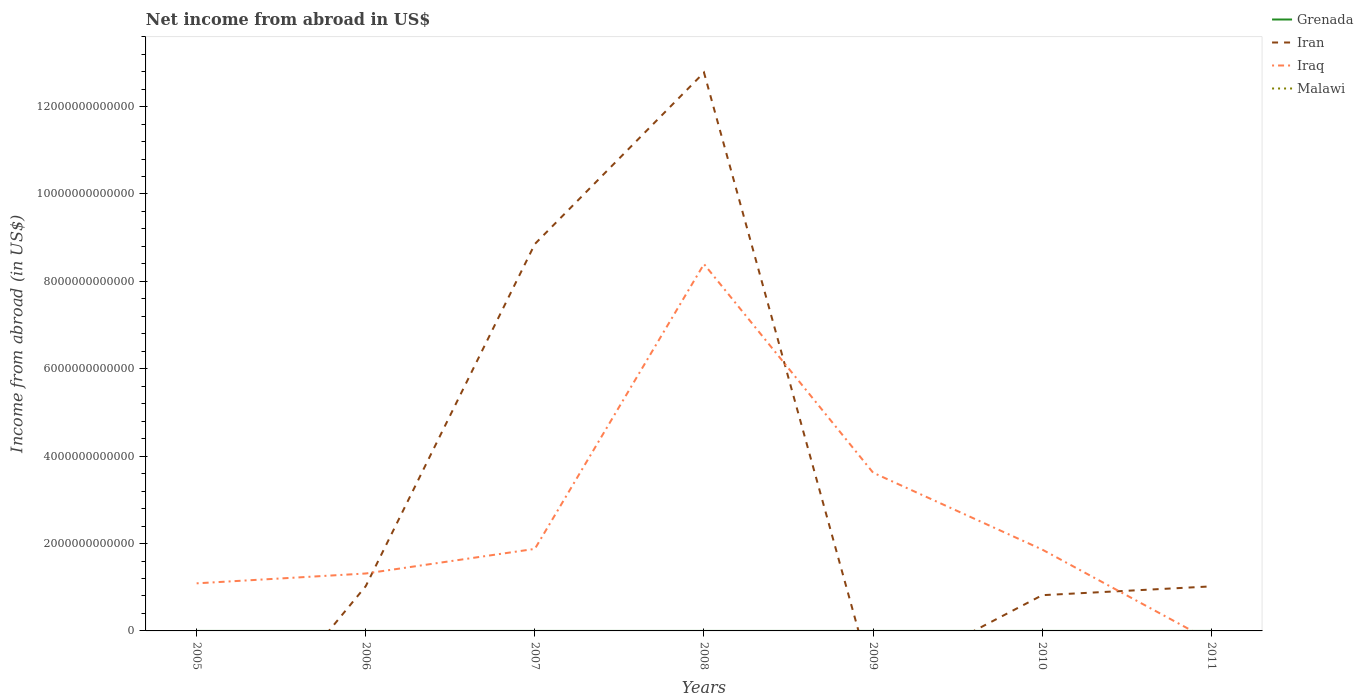How many different coloured lines are there?
Offer a terse response. 2. Does the line corresponding to Iran intersect with the line corresponding to Malawi?
Your answer should be compact. Yes. Is the number of lines equal to the number of legend labels?
Provide a succinct answer. No. What is the total net income from abroad in Iraq in the graph?
Make the answer very short. -7.31e+12. What is the difference between the highest and the second highest net income from abroad in Iraq?
Keep it short and to the point. 8.40e+12. Is the net income from abroad in Malawi strictly greater than the net income from abroad in Grenada over the years?
Ensure brevity in your answer.  Yes. How many years are there in the graph?
Provide a short and direct response. 7. What is the difference between two consecutive major ticks on the Y-axis?
Make the answer very short. 2.00e+12. Does the graph contain any zero values?
Your response must be concise. Yes. How many legend labels are there?
Give a very brief answer. 4. How are the legend labels stacked?
Ensure brevity in your answer.  Vertical. What is the title of the graph?
Your answer should be compact. Net income from abroad in US$. Does "Cuba" appear as one of the legend labels in the graph?
Provide a succinct answer. No. What is the label or title of the Y-axis?
Offer a very short reply. Income from abroad (in US$). What is the Income from abroad (in US$) of Grenada in 2005?
Ensure brevity in your answer.  0. What is the Income from abroad (in US$) of Iraq in 2005?
Ensure brevity in your answer.  1.09e+12. What is the Income from abroad (in US$) in Grenada in 2006?
Your answer should be compact. 0. What is the Income from abroad (in US$) of Iran in 2006?
Make the answer very short. 1.02e+12. What is the Income from abroad (in US$) in Iraq in 2006?
Provide a short and direct response. 1.31e+12. What is the Income from abroad (in US$) of Grenada in 2007?
Give a very brief answer. 0. What is the Income from abroad (in US$) of Iran in 2007?
Your response must be concise. 8.86e+12. What is the Income from abroad (in US$) in Iraq in 2007?
Your response must be concise. 1.88e+12. What is the Income from abroad (in US$) in Grenada in 2008?
Your answer should be very brief. 0. What is the Income from abroad (in US$) in Iran in 2008?
Give a very brief answer. 1.28e+13. What is the Income from abroad (in US$) of Iraq in 2008?
Provide a short and direct response. 8.40e+12. What is the Income from abroad (in US$) of Malawi in 2008?
Keep it short and to the point. 0. What is the Income from abroad (in US$) of Grenada in 2009?
Your answer should be compact. 0. What is the Income from abroad (in US$) in Iraq in 2009?
Give a very brief answer. 3.62e+12. What is the Income from abroad (in US$) in Grenada in 2010?
Make the answer very short. 0. What is the Income from abroad (in US$) in Iran in 2010?
Provide a succinct answer. 8.18e+11. What is the Income from abroad (in US$) in Iraq in 2010?
Give a very brief answer. 1.86e+12. What is the Income from abroad (in US$) in Iran in 2011?
Ensure brevity in your answer.  1.02e+12. What is the Income from abroad (in US$) in Malawi in 2011?
Offer a terse response. 0. Across all years, what is the maximum Income from abroad (in US$) of Iran?
Your response must be concise. 1.28e+13. Across all years, what is the maximum Income from abroad (in US$) of Iraq?
Your answer should be very brief. 8.40e+12. What is the total Income from abroad (in US$) in Iran in the graph?
Your answer should be compact. 2.45e+13. What is the total Income from abroad (in US$) in Iraq in the graph?
Ensure brevity in your answer.  1.82e+13. What is the total Income from abroad (in US$) of Malawi in the graph?
Keep it short and to the point. 0. What is the difference between the Income from abroad (in US$) in Iraq in 2005 and that in 2006?
Give a very brief answer. -2.25e+11. What is the difference between the Income from abroad (in US$) in Iraq in 2005 and that in 2007?
Make the answer very short. -7.88e+11. What is the difference between the Income from abroad (in US$) of Iraq in 2005 and that in 2008?
Provide a short and direct response. -7.31e+12. What is the difference between the Income from abroad (in US$) in Iraq in 2005 and that in 2009?
Keep it short and to the point. -2.53e+12. What is the difference between the Income from abroad (in US$) in Iraq in 2005 and that in 2010?
Make the answer very short. -7.73e+11. What is the difference between the Income from abroad (in US$) of Iran in 2006 and that in 2007?
Your answer should be compact. -7.83e+12. What is the difference between the Income from abroad (in US$) in Iraq in 2006 and that in 2007?
Your response must be concise. -5.63e+11. What is the difference between the Income from abroad (in US$) of Iran in 2006 and that in 2008?
Provide a short and direct response. -1.18e+13. What is the difference between the Income from abroad (in US$) in Iraq in 2006 and that in 2008?
Offer a terse response. -7.08e+12. What is the difference between the Income from abroad (in US$) of Iraq in 2006 and that in 2009?
Give a very brief answer. -2.31e+12. What is the difference between the Income from abroad (in US$) of Iran in 2006 and that in 2010?
Make the answer very short. 2.07e+11. What is the difference between the Income from abroad (in US$) in Iraq in 2006 and that in 2010?
Your answer should be compact. -5.48e+11. What is the difference between the Income from abroad (in US$) in Iran in 2006 and that in 2011?
Offer a very short reply. 4.86e+09. What is the difference between the Income from abroad (in US$) of Iran in 2007 and that in 2008?
Your response must be concise. -3.92e+12. What is the difference between the Income from abroad (in US$) in Iraq in 2007 and that in 2008?
Keep it short and to the point. -6.52e+12. What is the difference between the Income from abroad (in US$) in Iraq in 2007 and that in 2009?
Provide a short and direct response. -1.74e+12. What is the difference between the Income from abroad (in US$) of Iran in 2007 and that in 2010?
Offer a very short reply. 8.04e+12. What is the difference between the Income from abroad (in US$) in Iraq in 2007 and that in 2010?
Offer a terse response. 1.55e+1. What is the difference between the Income from abroad (in US$) of Iran in 2007 and that in 2011?
Your response must be concise. 7.84e+12. What is the difference between the Income from abroad (in US$) of Iraq in 2008 and that in 2009?
Offer a terse response. 4.77e+12. What is the difference between the Income from abroad (in US$) of Iran in 2008 and that in 2010?
Provide a short and direct response. 1.20e+13. What is the difference between the Income from abroad (in US$) of Iraq in 2008 and that in 2010?
Keep it short and to the point. 6.53e+12. What is the difference between the Income from abroad (in US$) in Iran in 2008 and that in 2011?
Provide a succinct answer. 1.18e+13. What is the difference between the Income from abroad (in US$) in Iraq in 2009 and that in 2010?
Offer a very short reply. 1.76e+12. What is the difference between the Income from abroad (in US$) of Iran in 2010 and that in 2011?
Ensure brevity in your answer.  -2.02e+11. What is the difference between the Income from abroad (in US$) in Iran in 2006 and the Income from abroad (in US$) in Iraq in 2007?
Provide a short and direct response. -8.53e+11. What is the difference between the Income from abroad (in US$) of Iran in 2006 and the Income from abroad (in US$) of Iraq in 2008?
Make the answer very short. -7.37e+12. What is the difference between the Income from abroad (in US$) in Iran in 2006 and the Income from abroad (in US$) in Iraq in 2009?
Offer a terse response. -2.60e+12. What is the difference between the Income from abroad (in US$) of Iran in 2006 and the Income from abroad (in US$) of Iraq in 2010?
Make the answer very short. -8.38e+11. What is the difference between the Income from abroad (in US$) in Iran in 2007 and the Income from abroad (in US$) in Iraq in 2008?
Your answer should be very brief. 4.59e+11. What is the difference between the Income from abroad (in US$) in Iran in 2007 and the Income from abroad (in US$) in Iraq in 2009?
Provide a short and direct response. 5.23e+12. What is the difference between the Income from abroad (in US$) in Iran in 2007 and the Income from abroad (in US$) in Iraq in 2010?
Give a very brief answer. 6.99e+12. What is the difference between the Income from abroad (in US$) in Iran in 2008 and the Income from abroad (in US$) in Iraq in 2009?
Provide a succinct answer. 9.16e+12. What is the difference between the Income from abroad (in US$) of Iran in 2008 and the Income from abroad (in US$) of Iraq in 2010?
Ensure brevity in your answer.  1.09e+13. What is the average Income from abroad (in US$) of Grenada per year?
Offer a very short reply. 0. What is the average Income from abroad (in US$) of Iran per year?
Make the answer very short. 3.50e+12. What is the average Income from abroad (in US$) in Iraq per year?
Offer a very short reply. 2.59e+12. What is the average Income from abroad (in US$) in Malawi per year?
Offer a very short reply. 0. In the year 2006, what is the difference between the Income from abroad (in US$) of Iran and Income from abroad (in US$) of Iraq?
Offer a terse response. -2.90e+11. In the year 2007, what is the difference between the Income from abroad (in US$) of Iran and Income from abroad (in US$) of Iraq?
Your answer should be very brief. 6.98e+12. In the year 2008, what is the difference between the Income from abroad (in US$) in Iran and Income from abroad (in US$) in Iraq?
Provide a succinct answer. 4.38e+12. In the year 2010, what is the difference between the Income from abroad (in US$) of Iran and Income from abroad (in US$) of Iraq?
Ensure brevity in your answer.  -1.04e+12. What is the ratio of the Income from abroad (in US$) of Iraq in 2005 to that in 2006?
Your answer should be compact. 0.83. What is the ratio of the Income from abroad (in US$) of Iraq in 2005 to that in 2007?
Your answer should be compact. 0.58. What is the ratio of the Income from abroad (in US$) of Iraq in 2005 to that in 2008?
Offer a very short reply. 0.13. What is the ratio of the Income from abroad (in US$) in Iraq in 2005 to that in 2009?
Your answer should be very brief. 0.3. What is the ratio of the Income from abroad (in US$) in Iraq in 2005 to that in 2010?
Keep it short and to the point. 0.58. What is the ratio of the Income from abroad (in US$) of Iran in 2006 to that in 2007?
Your response must be concise. 0.12. What is the ratio of the Income from abroad (in US$) in Iraq in 2006 to that in 2007?
Offer a terse response. 0.7. What is the ratio of the Income from abroad (in US$) of Iran in 2006 to that in 2008?
Provide a succinct answer. 0.08. What is the ratio of the Income from abroad (in US$) of Iraq in 2006 to that in 2008?
Give a very brief answer. 0.16. What is the ratio of the Income from abroad (in US$) in Iraq in 2006 to that in 2009?
Make the answer very short. 0.36. What is the ratio of the Income from abroad (in US$) in Iran in 2006 to that in 2010?
Offer a terse response. 1.25. What is the ratio of the Income from abroad (in US$) of Iraq in 2006 to that in 2010?
Your answer should be very brief. 0.71. What is the ratio of the Income from abroad (in US$) in Iran in 2006 to that in 2011?
Offer a terse response. 1. What is the ratio of the Income from abroad (in US$) in Iran in 2007 to that in 2008?
Your response must be concise. 0.69. What is the ratio of the Income from abroad (in US$) of Iraq in 2007 to that in 2008?
Make the answer very short. 0.22. What is the ratio of the Income from abroad (in US$) of Iraq in 2007 to that in 2009?
Your answer should be compact. 0.52. What is the ratio of the Income from abroad (in US$) of Iran in 2007 to that in 2010?
Your response must be concise. 10.83. What is the ratio of the Income from abroad (in US$) of Iraq in 2007 to that in 2010?
Provide a succinct answer. 1.01. What is the ratio of the Income from abroad (in US$) in Iran in 2007 to that in 2011?
Your answer should be compact. 8.69. What is the ratio of the Income from abroad (in US$) in Iraq in 2008 to that in 2009?
Your answer should be very brief. 2.32. What is the ratio of the Income from abroad (in US$) of Iran in 2008 to that in 2010?
Your response must be concise. 15.63. What is the ratio of the Income from abroad (in US$) of Iraq in 2008 to that in 2010?
Keep it short and to the point. 4.51. What is the ratio of the Income from abroad (in US$) in Iran in 2008 to that in 2011?
Your response must be concise. 12.54. What is the ratio of the Income from abroad (in US$) of Iraq in 2009 to that in 2010?
Give a very brief answer. 1.94. What is the ratio of the Income from abroad (in US$) in Iran in 2010 to that in 2011?
Give a very brief answer. 0.8. What is the difference between the highest and the second highest Income from abroad (in US$) of Iran?
Your response must be concise. 3.92e+12. What is the difference between the highest and the second highest Income from abroad (in US$) of Iraq?
Provide a short and direct response. 4.77e+12. What is the difference between the highest and the lowest Income from abroad (in US$) in Iran?
Your answer should be compact. 1.28e+13. What is the difference between the highest and the lowest Income from abroad (in US$) in Iraq?
Provide a succinct answer. 8.40e+12. 